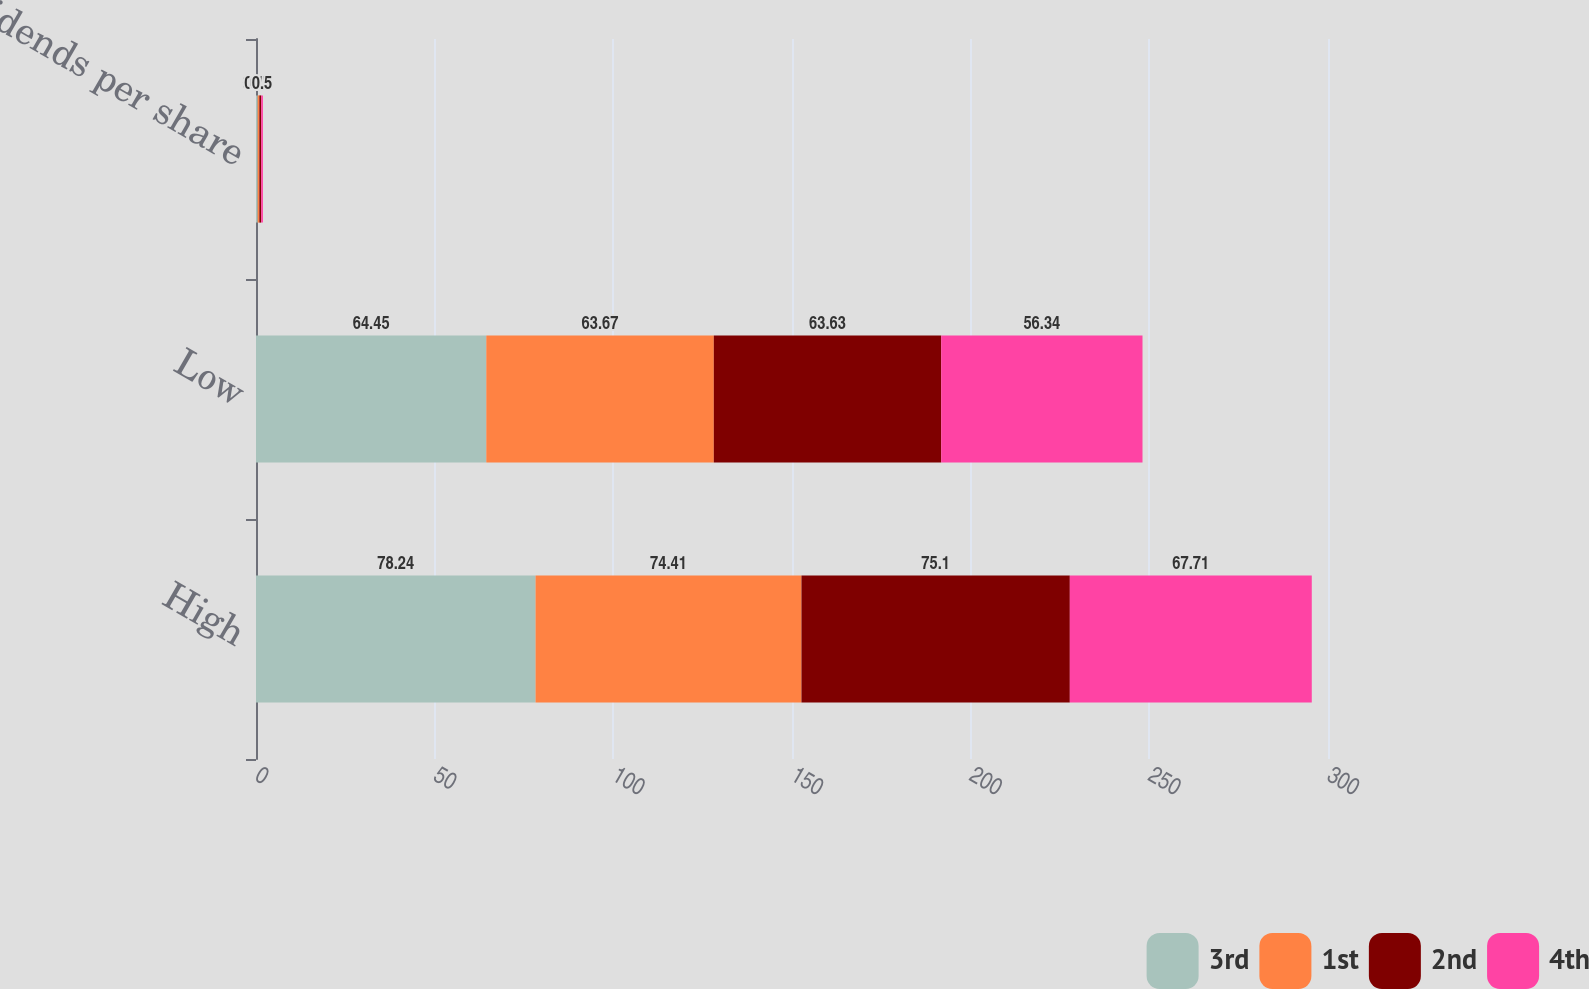<chart> <loc_0><loc_0><loc_500><loc_500><stacked_bar_chart><ecel><fcel>High<fcel>Low<fcel>Dividends per share<nl><fcel>3rd<fcel>78.24<fcel>64.45<fcel>0.47<nl><fcel>1st<fcel>74.41<fcel>63.67<fcel>0.47<nl><fcel>2nd<fcel>75.1<fcel>63.63<fcel>0.5<nl><fcel>4th<fcel>67.71<fcel>56.34<fcel>0.5<nl></chart> 